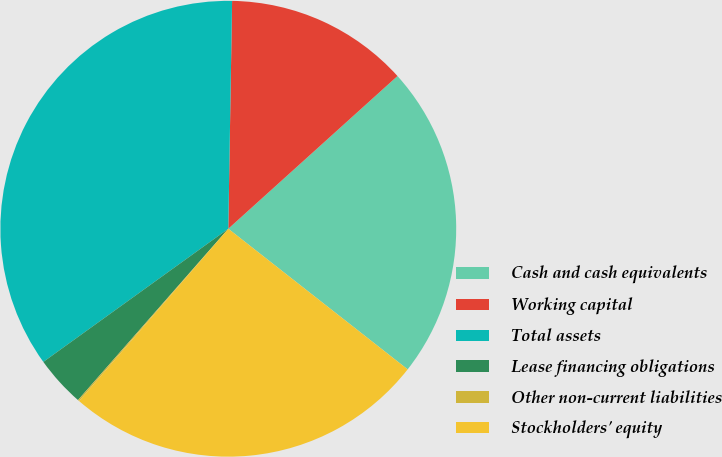<chart> <loc_0><loc_0><loc_500><loc_500><pie_chart><fcel>Cash and cash equivalents<fcel>Working capital<fcel>Total assets<fcel>Lease financing obligations<fcel>Other non-current liabilities<fcel>Stockholders' equity<nl><fcel>22.27%<fcel>13.05%<fcel>35.2%<fcel>3.61%<fcel>0.1%<fcel>25.78%<nl></chart> 